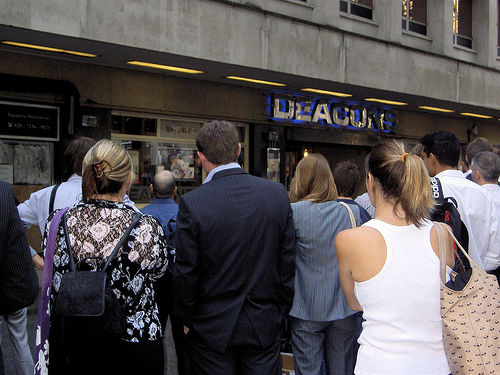<image>
Is the lady in front of the building? Yes. The lady is positioned in front of the building, appearing closer to the camera viewpoint. 